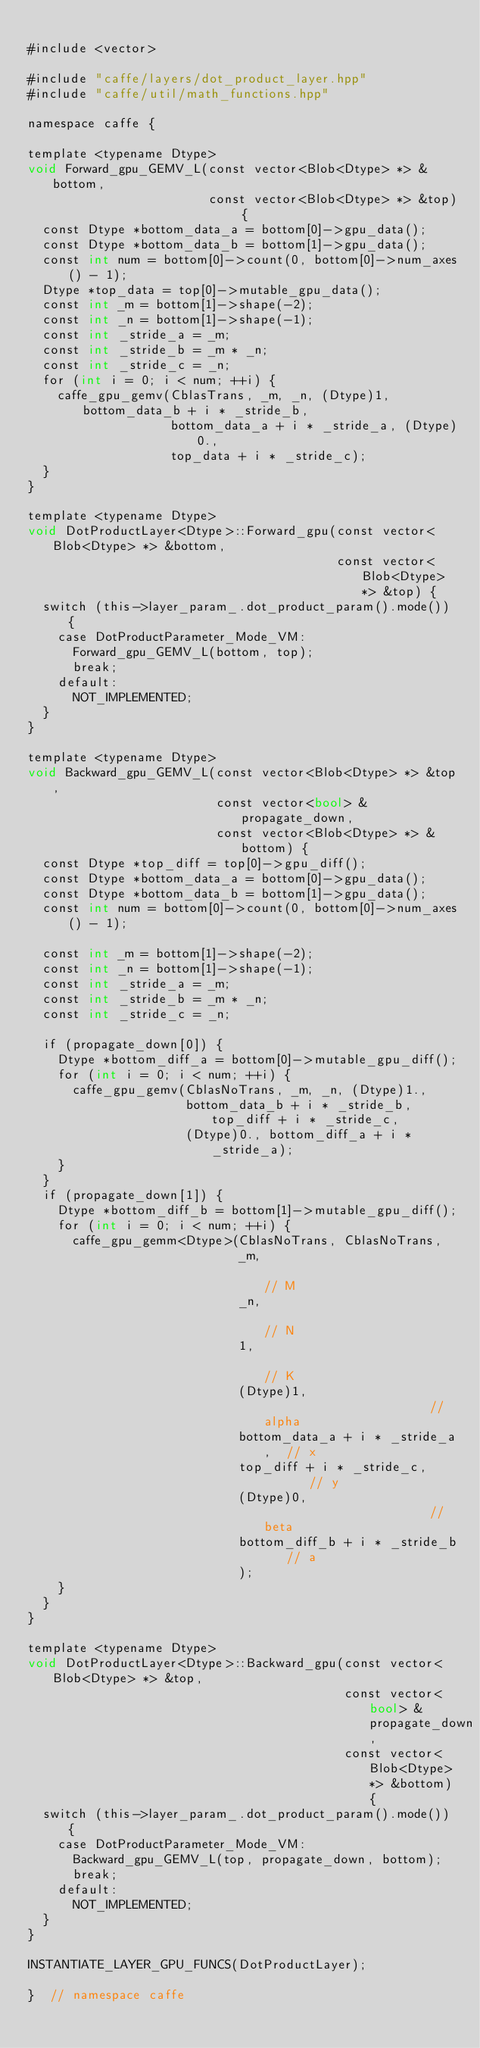<code> <loc_0><loc_0><loc_500><loc_500><_Cuda_>
#include <vector>

#include "caffe/layers/dot_product_layer.hpp"
#include "caffe/util/math_functions.hpp"

namespace caffe {

template <typename Dtype>
void Forward_gpu_GEMV_L(const vector<Blob<Dtype> *> &bottom,
                        const vector<Blob<Dtype> *> &top) {
  const Dtype *bottom_data_a = bottom[0]->gpu_data();
  const Dtype *bottom_data_b = bottom[1]->gpu_data();
  const int num = bottom[0]->count(0, bottom[0]->num_axes() - 1);
  Dtype *top_data = top[0]->mutable_gpu_data();
  const int _m = bottom[1]->shape(-2);
  const int _n = bottom[1]->shape(-1);
  const int _stride_a = _m;
  const int _stride_b = _m * _n;
  const int _stride_c = _n;
  for (int i = 0; i < num; ++i) {
    caffe_gpu_gemv(CblasTrans, _m, _n, (Dtype)1, bottom_data_b + i * _stride_b,
                   bottom_data_a + i * _stride_a, (Dtype)0.,
                   top_data + i * _stride_c);
  }
}

template <typename Dtype>
void DotProductLayer<Dtype>::Forward_gpu(const vector<Blob<Dtype> *> &bottom,
                                         const vector<Blob<Dtype> *> &top) {
  switch (this->layer_param_.dot_product_param().mode()) {
    case DotProductParameter_Mode_VM:
      Forward_gpu_GEMV_L(bottom, top);
      break;
    default:
      NOT_IMPLEMENTED;
  }
}

template <typename Dtype>
void Backward_gpu_GEMV_L(const vector<Blob<Dtype> *> &top,
                         const vector<bool> &propagate_down,
                         const vector<Blob<Dtype> *> &bottom) {
  const Dtype *top_diff = top[0]->gpu_diff();
  const Dtype *bottom_data_a = bottom[0]->gpu_data();
  const Dtype *bottom_data_b = bottom[1]->gpu_data();
  const int num = bottom[0]->count(0, bottom[0]->num_axes() - 1);

  const int _m = bottom[1]->shape(-2);
  const int _n = bottom[1]->shape(-1);
  const int _stride_a = _m;
  const int _stride_b = _m * _n;
  const int _stride_c = _n;

  if (propagate_down[0]) {
    Dtype *bottom_diff_a = bottom[0]->mutable_gpu_diff();
    for (int i = 0; i < num; ++i) {
      caffe_gpu_gemv(CblasNoTrans, _m, _n, (Dtype)1.,
                     bottom_data_b + i * _stride_b, top_diff + i * _stride_c,
                     (Dtype)0., bottom_diff_a + i * _stride_a);
    }
  }
  if (propagate_down[1]) {
    Dtype *bottom_diff_b = bottom[1]->mutable_gpu_diff();
    for (int i = 0; i < num; ++i) {
      caffe_gpu_gemm<Dtype>(CblasNoTrans, CblasNoTrans,
                            _m,                             // M
                            _n,                             // N
                            1,                              // K
                            (Dtype)1,                       // alpha
                            bottom_data_a + i * _stride_a,  // x
                            top_diff + i * _stride_c,       // y
                            (Dtype)0,                       // beta
                            bottom_diff_b + i * _stride_b   // a
                            );
    }
  }
}

template <typename Dtype>
void DotProductLayer<Dtype>::Backward_gpu(const vector<Blob<Dtype> *> &top,
                                          const vector<bool> &propagate_down,
                                          const vector<Blob<Dtype> *> &bottom) {
  switch (this->layer_param_.dot_product_param().mode()) {
    case DotProductParameter_Mode_VM:
      Backward_gpu_GEMV_L(top, propagate_down, bottom);
      break;
    default:
      NOT_IMPLEMENTED;
  }
}

INSTANTIATE_LAYER_GPU_FUNCS(DotProductLayer);

}  // namespace caffe
</code> 